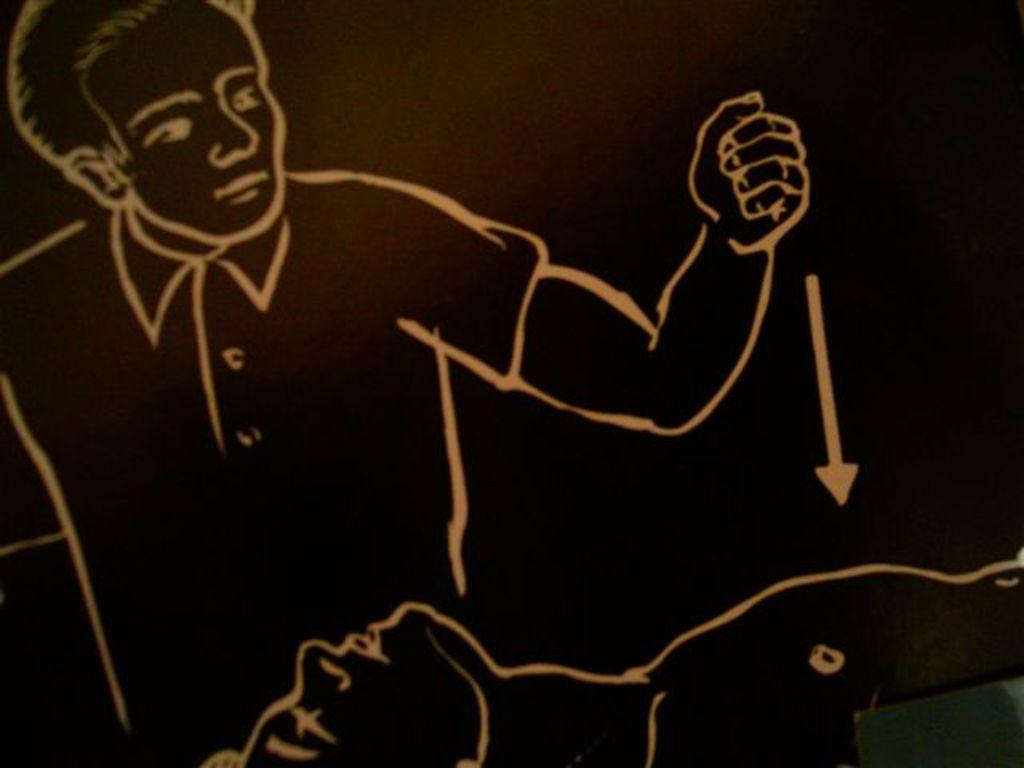What is the main subject of the painting in the image? There is a painting of a person in the image. What color is the background of the painting? The background of the image is black. What arithmetic problem is the person solving in the painting? There is no arithmetic problem visible in the painting; it only depicts a person. How many sisters does the person in the painting have? There is no information about the person's family or number of sisters in the image. 